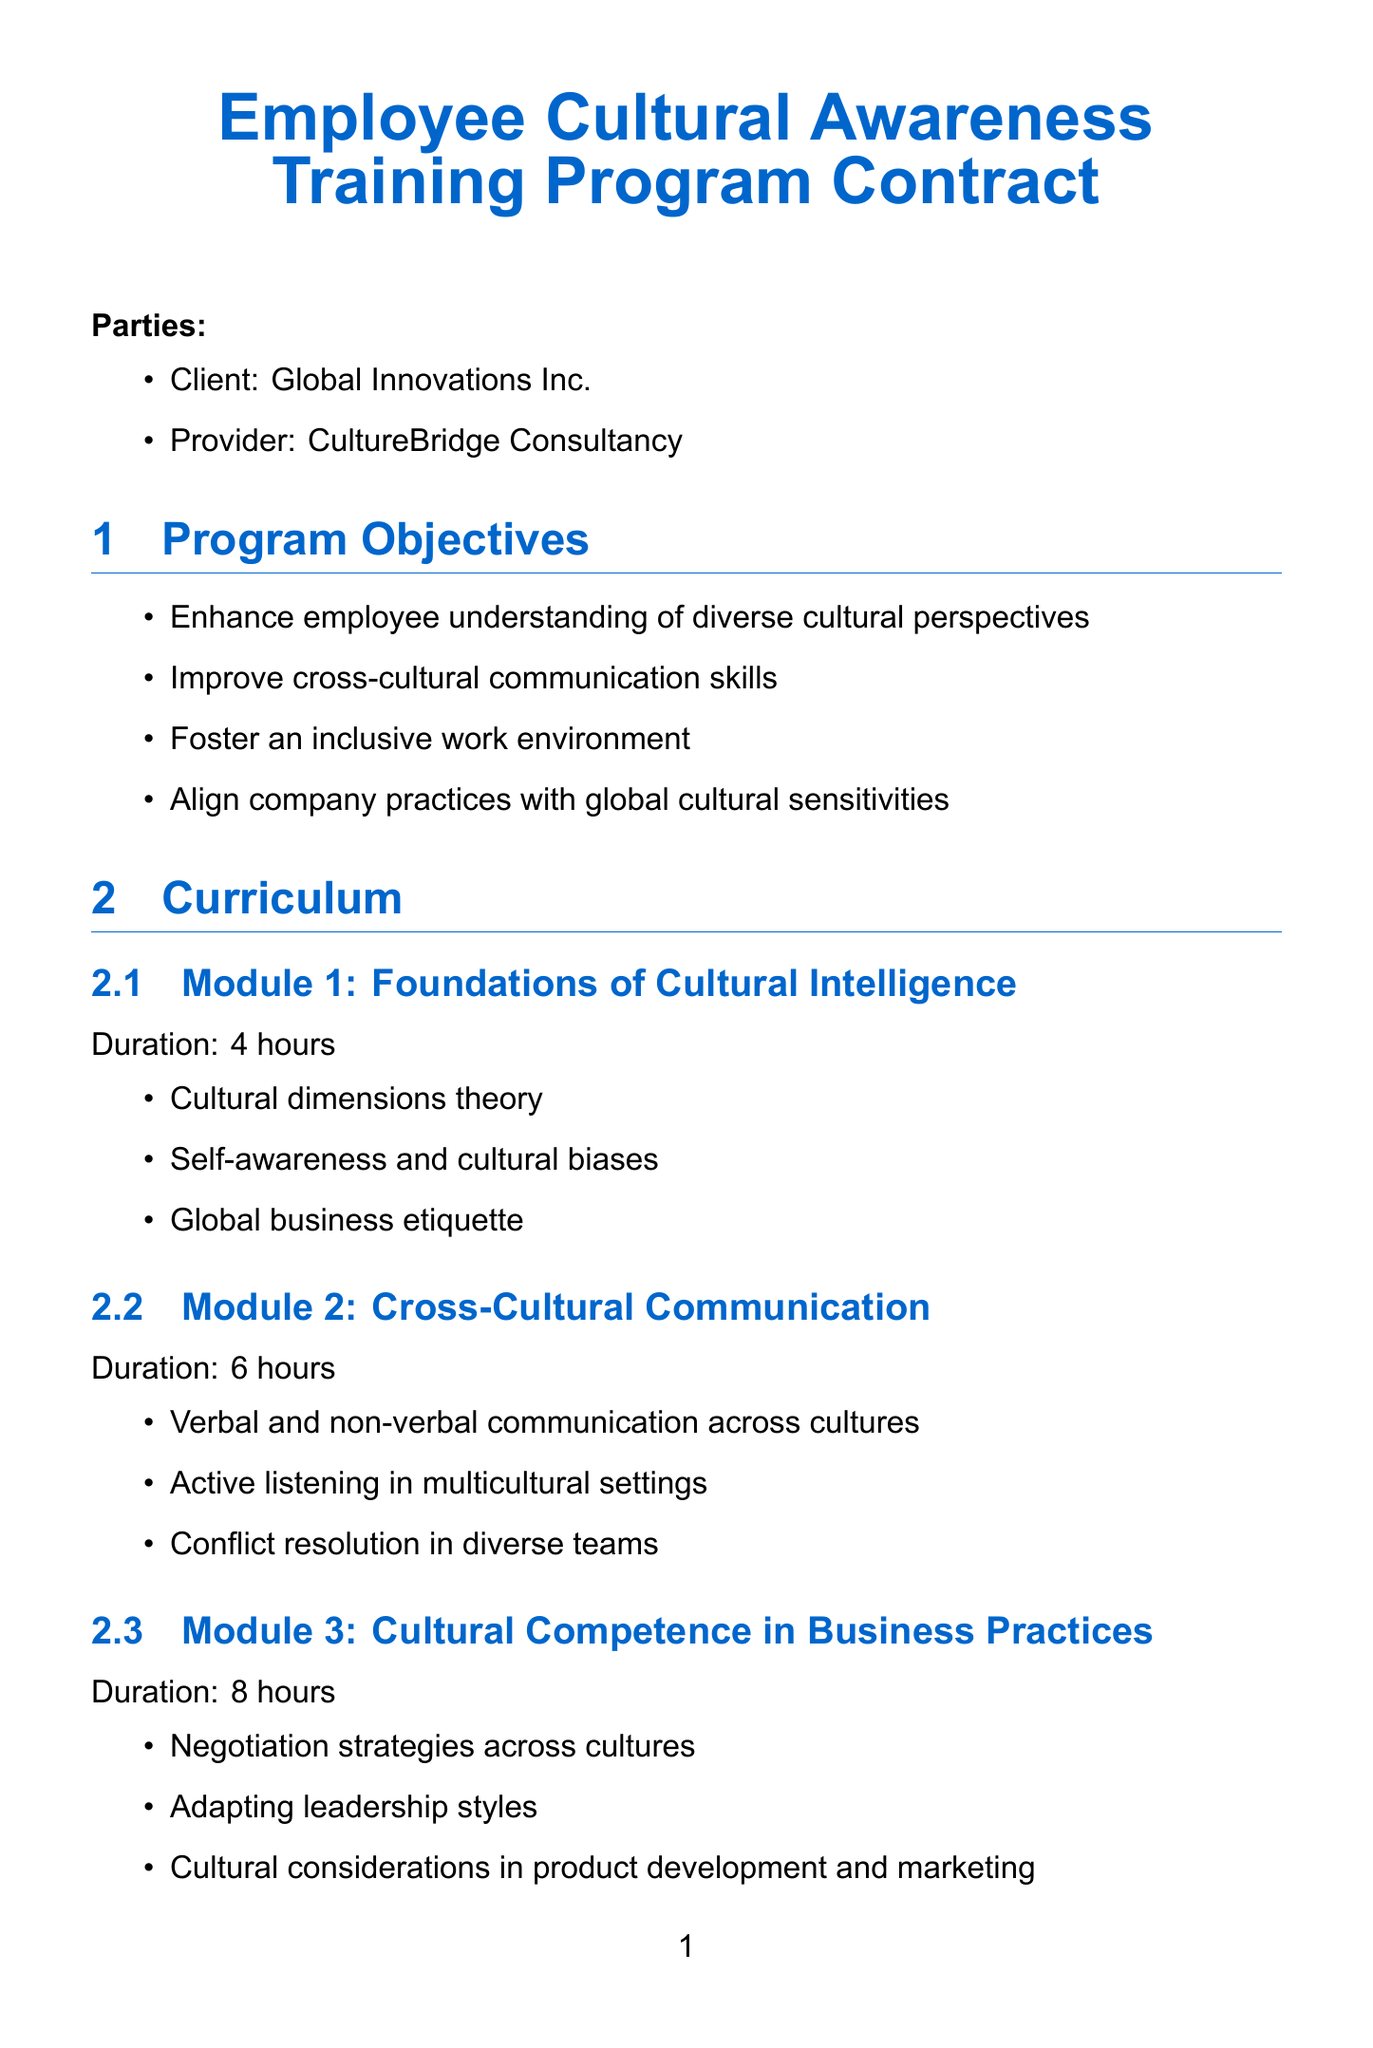What is the client company name? The client company is named in the contract section that identifies the parties involved.
Answer: Global Innovations Inc Who is the service provider? The service provider is specified in the same section as the client company.
Answer: CultureBridge Consultancy What is the duration of Module 3? The duration of Module 3 is stated in the curriculum section, detailing the hours allotted.
Answer: 8 hours How many key performance indicators are listed? The short answer can be found in the specific section addressing key performance metrics.
Answer: 4 What is the total base fee? The total base fee for the training program is stated under the pricing section.
Answer: $75,000 What is the duration of the implementation timeline for Phase 1? Phase 1 duration is explicitly mentioned in the implementation timeline section.
Answer: 2 weeks What delivery method involves live interaction? The delivery methods include various formats, where one method explicitly states live interaction.
Answer: Virtual live sessions What percentage of the base fee is due at contract signing? The payment schedule specifies the percentage due upon contract signing.
Answer: 30% What clause allows for contract termination? The contract contains specific provisions that discuss the termination process.
Answer: Termination Clause 